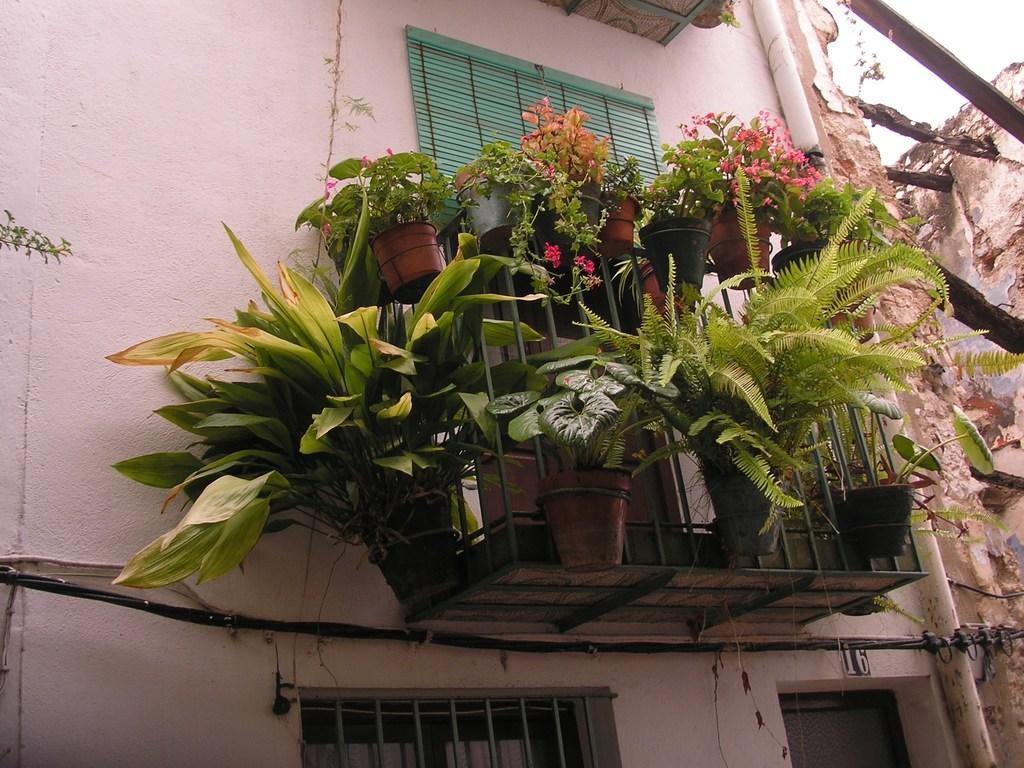Please provide a concise description of this image. There is a building. On the building there are windows, curtains and pipes. Near the window there are stands attached to the wall. On that there are pots with plants. 